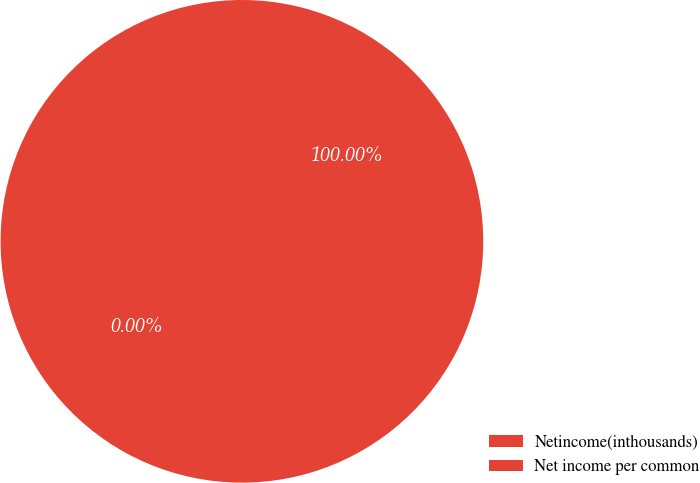Convert chart. <chart><loc_0><loc_0><loc_500><loc_500><pie_chart><fcel>Netincome(inthousands)<fcel>Net income per common<nl><fcel>100.0%<fcel>0.0%<nl></chart> 